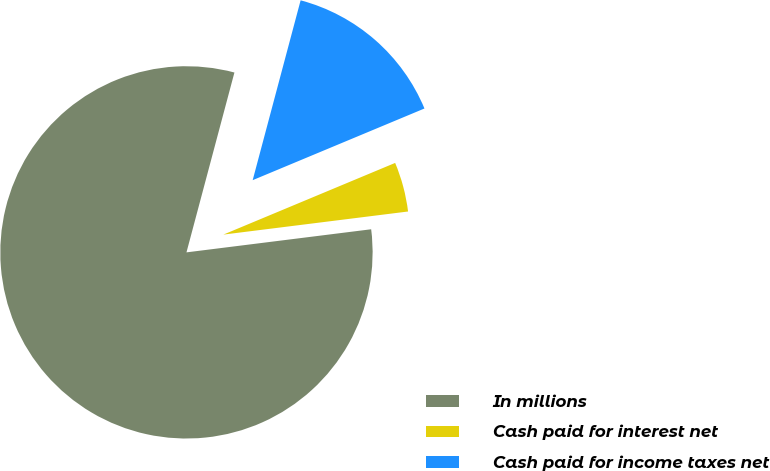Convert chart to OTSL. <chart><loc_0><loc_0><loc_500><loc_500><pie_chart><fcel>In millions<fcel>Cash paid for interest net<fcel>Cash paid for income taxes net<nl><fcel>81.12%<fcel>4.31%<fcel>14.56%<nl></chart> 